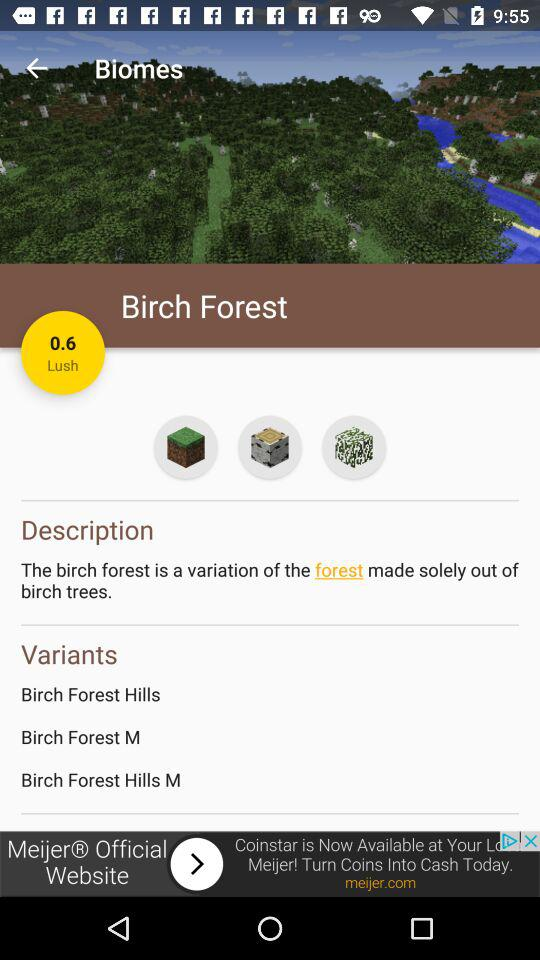What are the variants of Birch Forest? The variants are "Birch Forest Hills", "Birch Forest M" and "Birch Forest Hills M". 